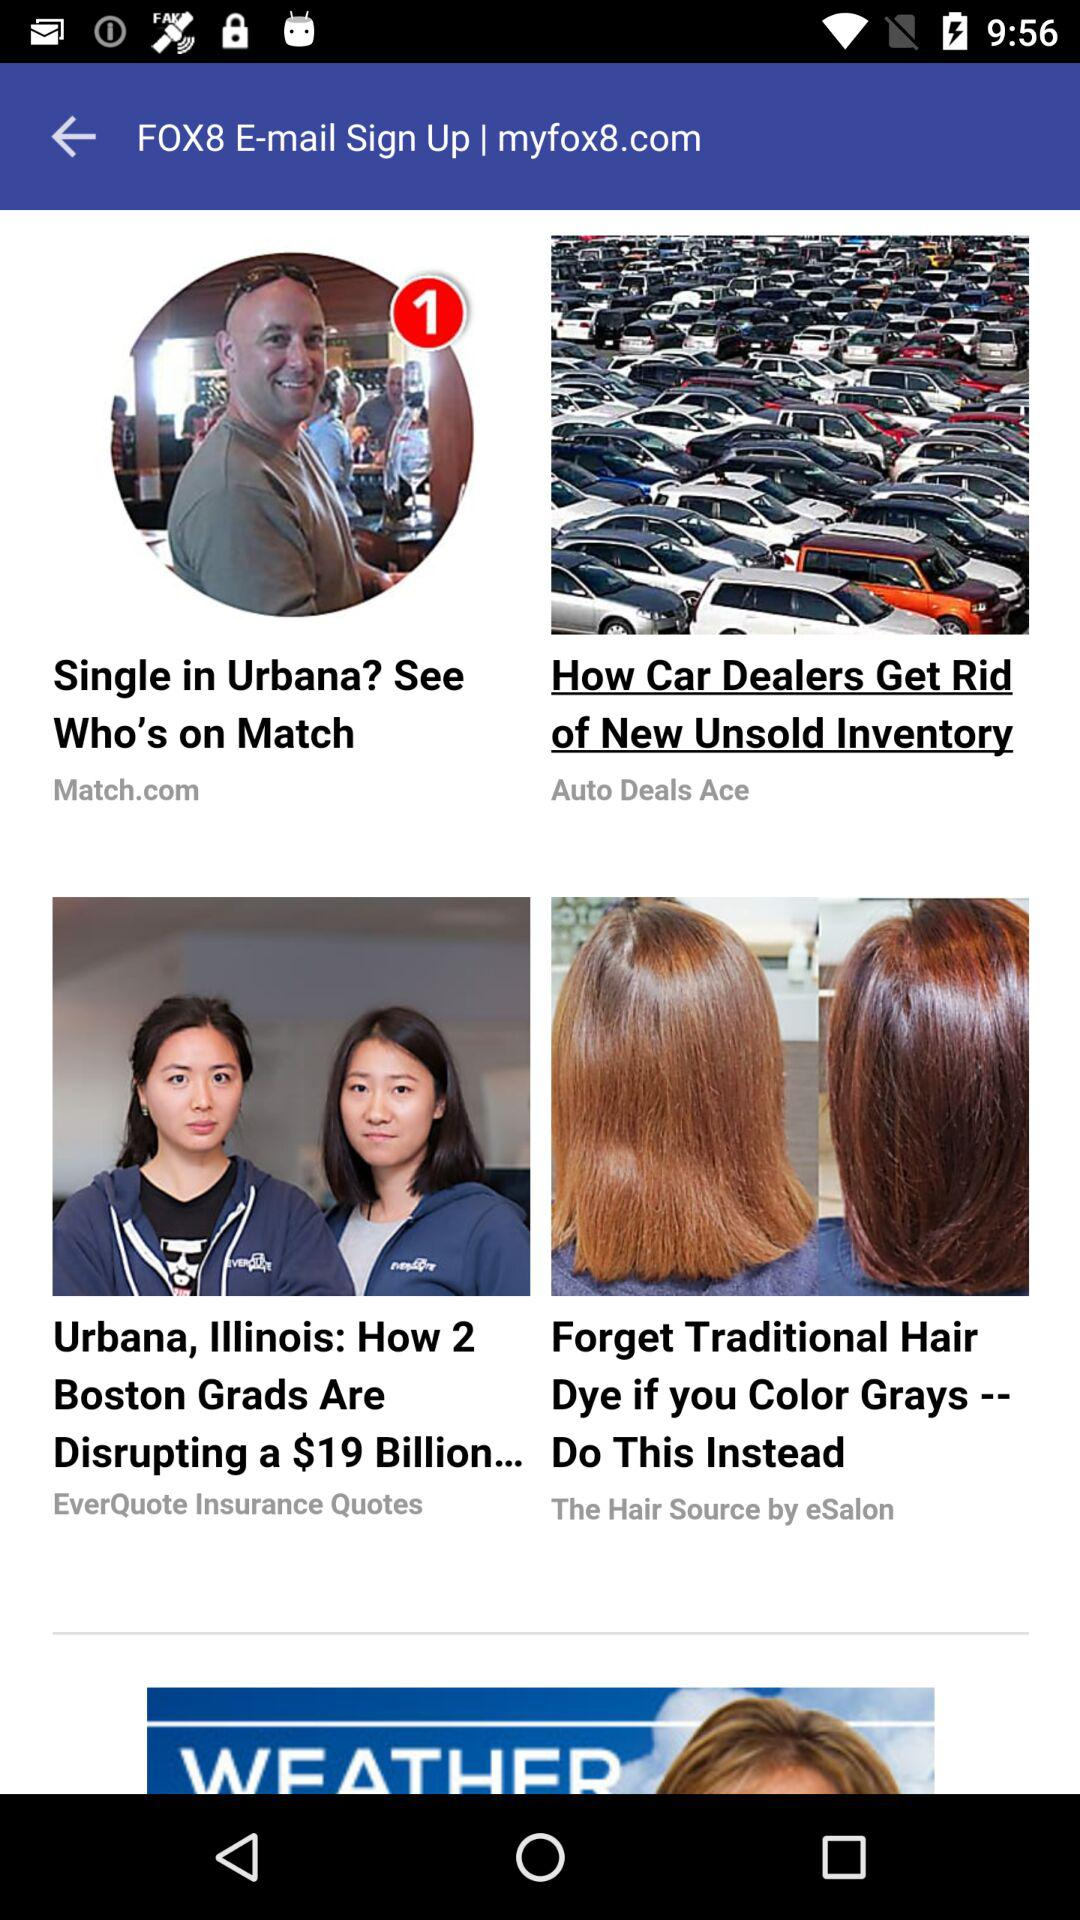What is the name of the application? The name of the application is "FOX8". 